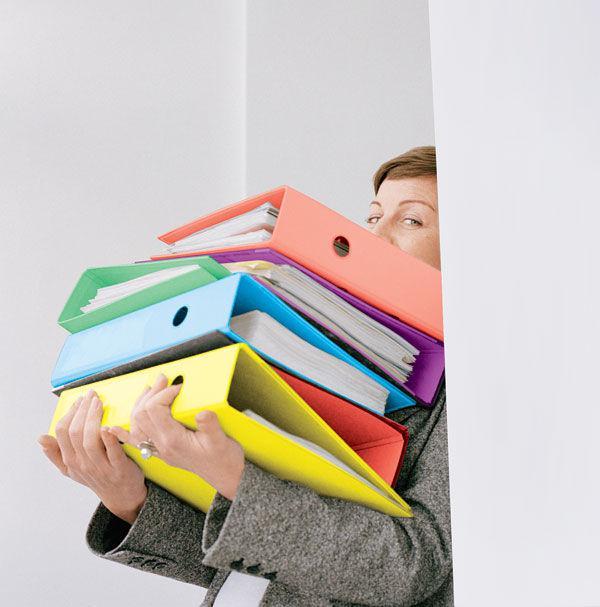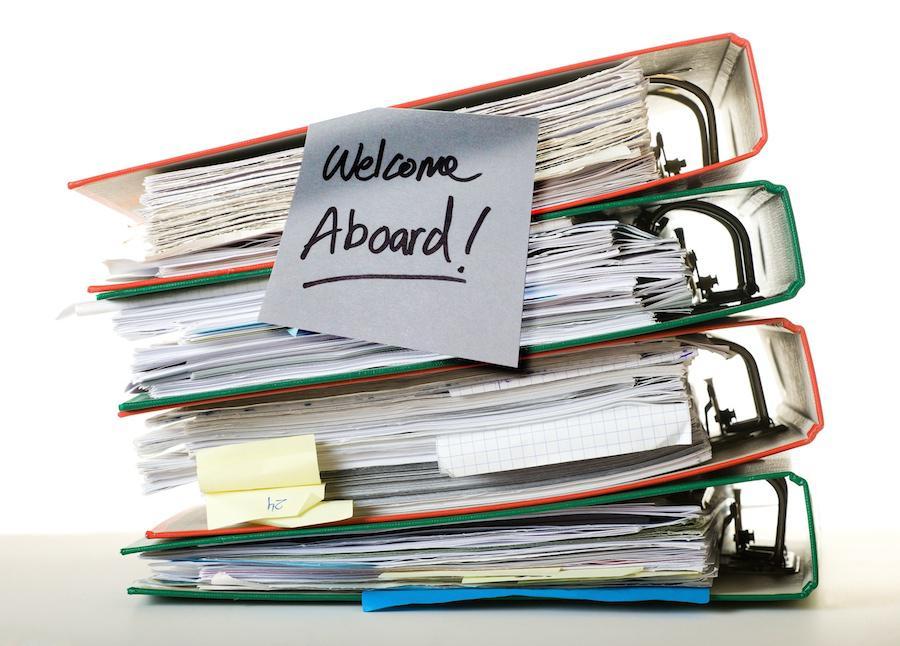The first image is the image on the left, the second image is the image on the right. Considering the images on both sides, is "A person is gripping multiple different colored binders in one of the images." valid? Answer yes or no. Yes. 